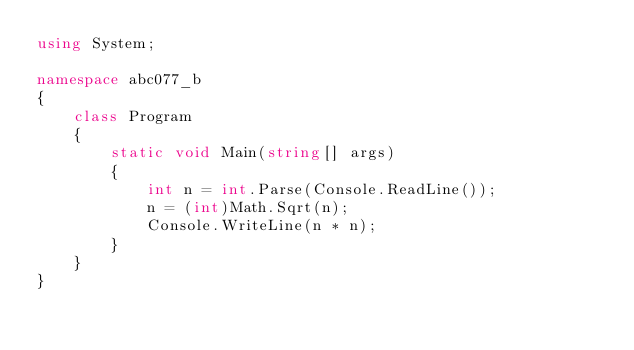Convert code to text. <code><loc_0><loc_0><loc_500><loc_500><_C#_>using System;

namespace abc077_b
{
    class Program
    {
        static void Main(string[] args)
        {
            int n = int.Parse(Console.ReadLine());
            n = (int)Math.Sqrt(n);
            Console.WriteLine(n * n);
        }
    }
}</code> 